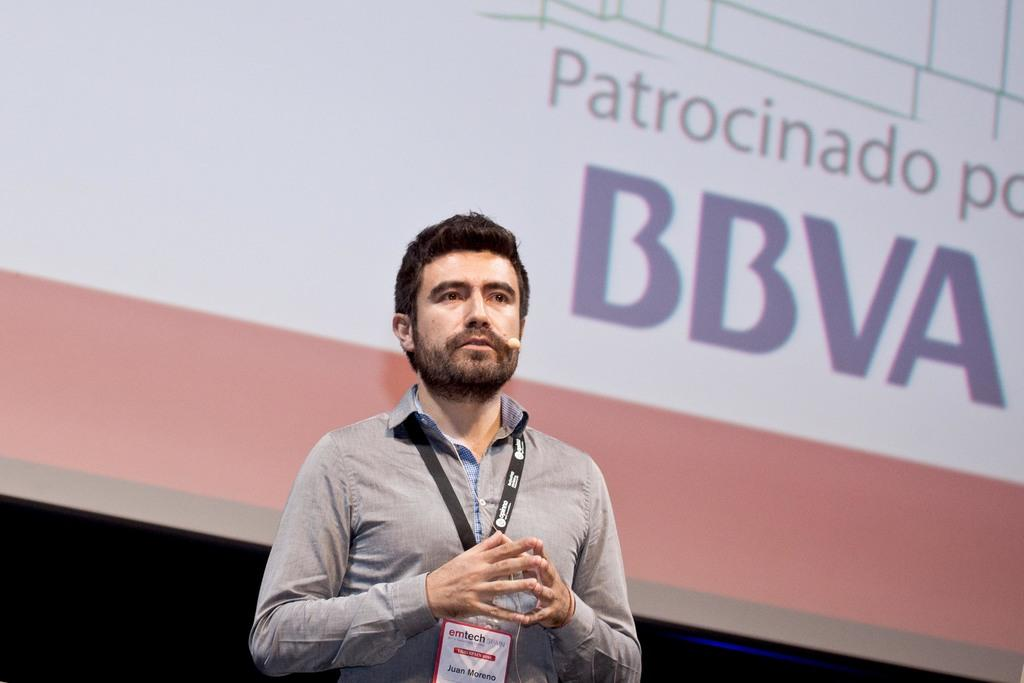<image>
Create a compact narrative representing the image presented. a man standing next to a BBVA sign 